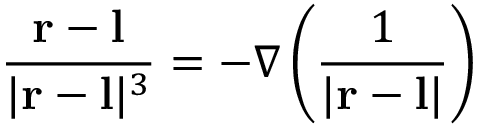<formula> <loc_0><loc_0><loc_500><loc_500>{ \frac { r - l } { | r - l | ^ { 3 } } } = - \nabla \left ( { \frac { 1 } { | r - l | } } \right )</formula> 